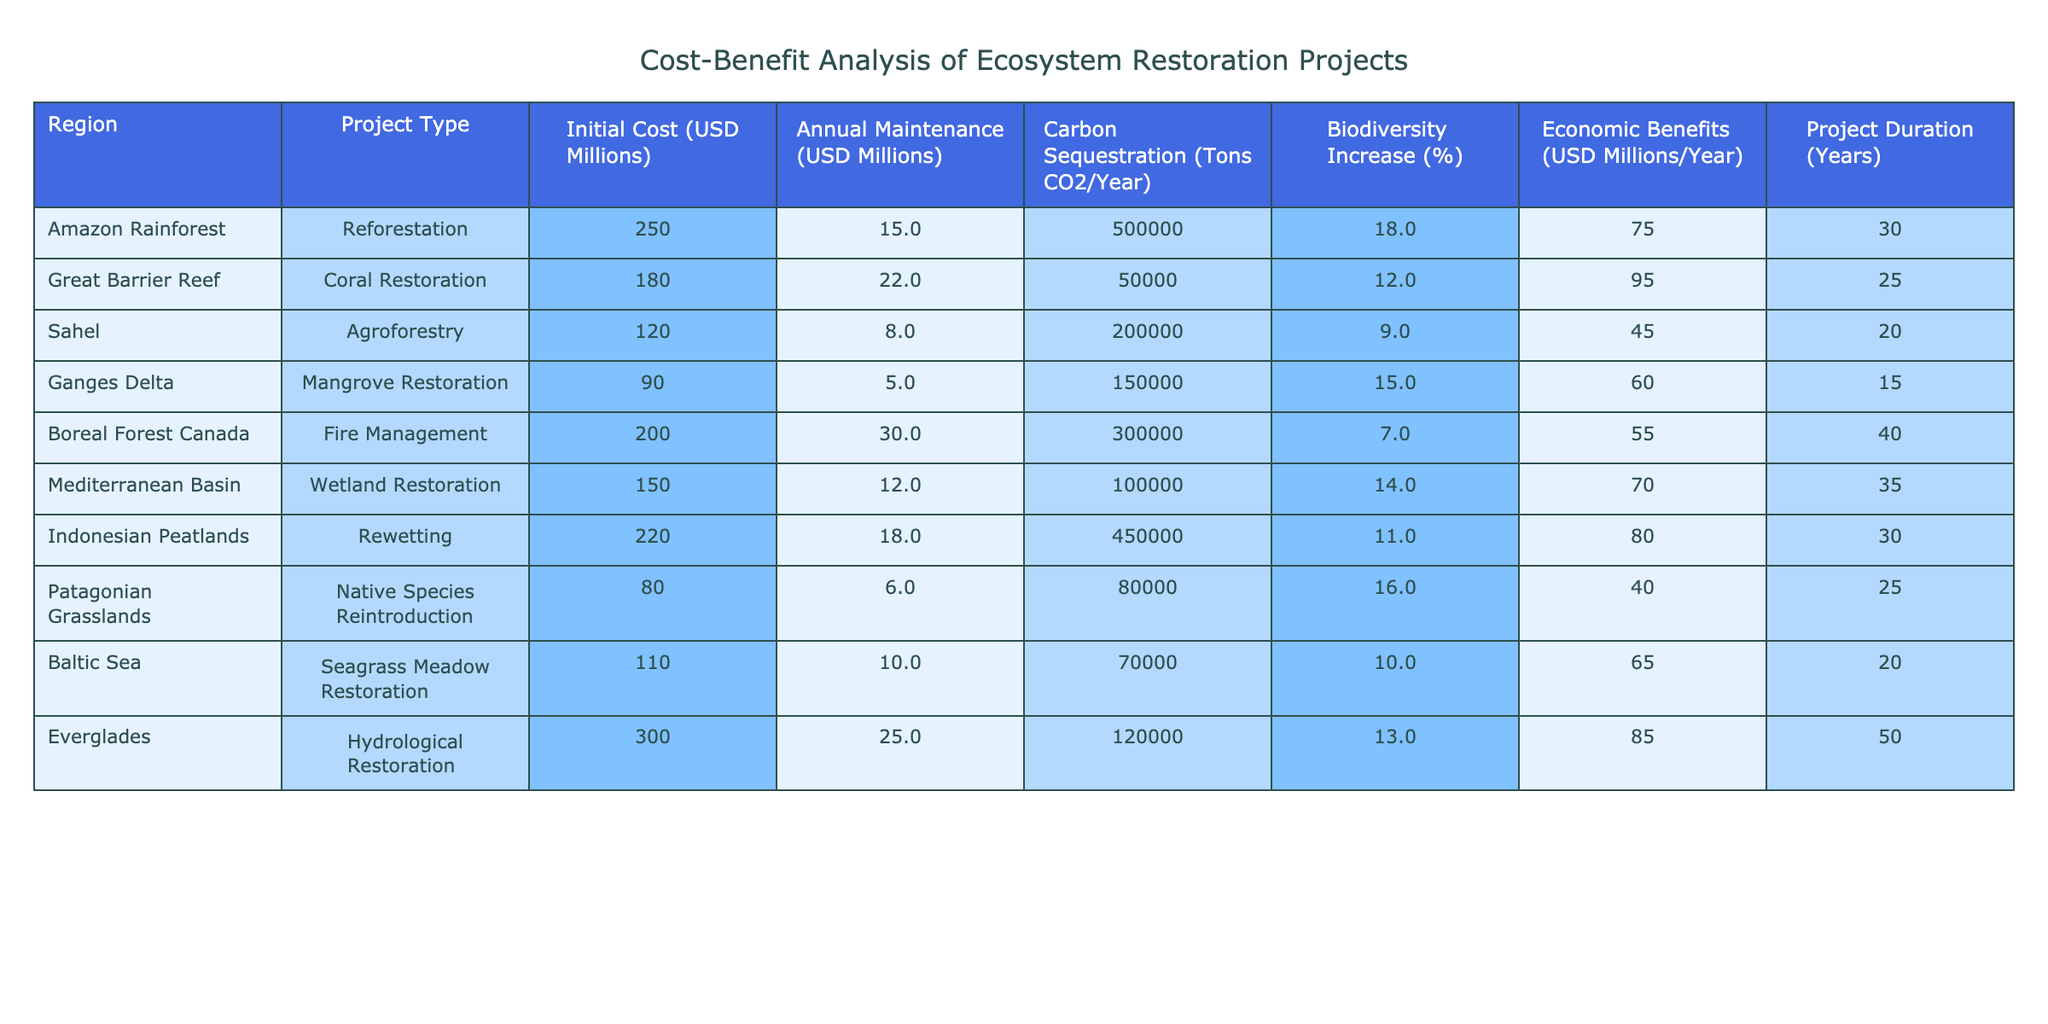What is the initial cost of the Ganges Delta mangrove restoration project? The table shows that the initial cost for the Ganges Delta mangrove restoration project is listed in the "Initial Cost (USD Millions)" column, which specifies an amount of 90 million USD.
Answer: 90 million USD Which project has the highest economic benefits per year? By comparing the values in the "Economic Benefits (USD Millions/Year)" column, the Great Barrier Reef coral restoration project has the highest economic benefits at 95 million USD per year.
Answer: Great Barrier Reef What is the average initial cost of all projects listed in the table? To find the average initial cost, sum the initial costs (250 + 180 + 120 + 90 + 200 + 150 + 220 + 80 + 110 + 300 = 1800 million USD) and divide by the number of projects (10). The average initial cost is therefore 1800/10 = 180 million USD.
Answer: 180 million USD Is the biodiversity increase for the Boreal Forest Canada project greater than that of the Amazon Rainforest? The table shows a biodiversity increase of 7% for Boreal Forest Canada and 18% for Amazon Rainforest. Since 18% is greater than 7%, the statement is true.
Answer: Yes What is the total carbon sequestration potential (in tons CO2/year) for the top three projects based on this metric? Identify the top three projects based on carbon sequestration from the table: Amazon Rainforest (500,000), Indonesian Peatlands (450,000), and Boreal Forest Canada (300,000). Summing these gives 500,000 + 450,000 + 300,000 = 1,250,000 tons CO2/year.
Answer: 1,250,000 tons CO2/year What is the difference in annual maintenance cost between the Great Barrier Reef project and the Ganges Delta project? The annual maintenance costs are 22 million USD for Great Barrier Reef and 5 million USD for Ganges Delta. The difference is 22 - 5 = 17 million USD.
Answer: 17 million USD In which project type is the economic benefit per initial cost ratio the highest, and what is that ratio? Calculate the ratio for each project by dividing the economic benefits by the initial cost. For example, Amazon Rainforest has a ratio of 75/250 = 0.3. After performing this for all, the highest ratio is from Great Barrier Reef (95/180 = 0.5278).
Answer: Great Barrier Reef, 0.5278 Does the Patagonian Grasslands project have an annual maintenance cost lower than 10 million USD? The annual maintenance cost for the Patagonian Grasslands project is 6 million USD, which is indeed lower than 10 million USD, making the statement true.
Answer: Yes What project has the longest duration, and how long is it? The project with the longest duration is the Everglades hydrological restoration project, which lasts for 50 years as indicated in the "Project Duration (Years)" column.
Answer: Everglades, 50 years What is the total economic benefit from all the restoration projects in the table? Sum the economic benefits listed for each project: 75 + 95 + 45 + 60 + 55 + 70 + 80 + 40 + 65 + 85 = 725 million USD per year.
Answer: 725 million USD per year 